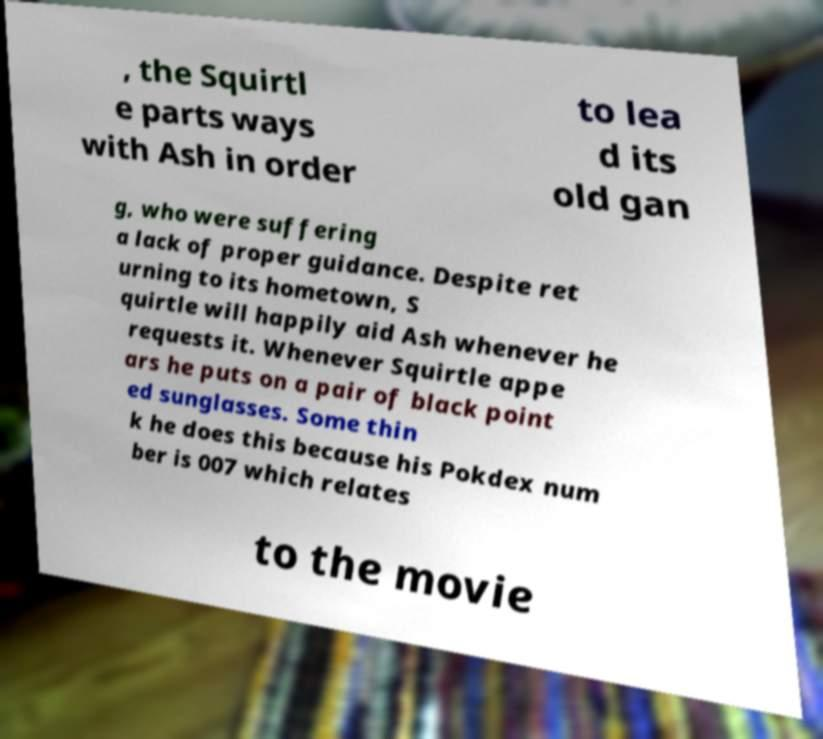There's text embedded in this image that I need extracted. Can you transcribe it verbatim? , the Squirtl e parts ways with Ash in order to lea d its old gan g, who were suffering a lack of proper guidance. Despite ret urning to its hometown, S quirtle will happily aid Ash whenever he requests it. Whenever Squirtle appe ars he puts on a pair of black point ed sunglasses. Some thin k he does this because his Pokdex num ber is 007 which relates to the movie 